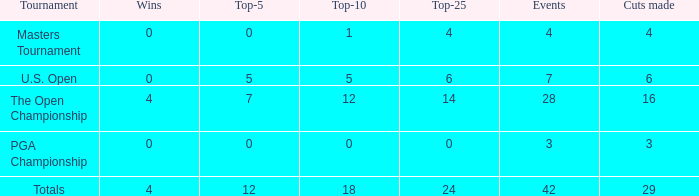What is the event average for a top-25 smaller than 0? None. 